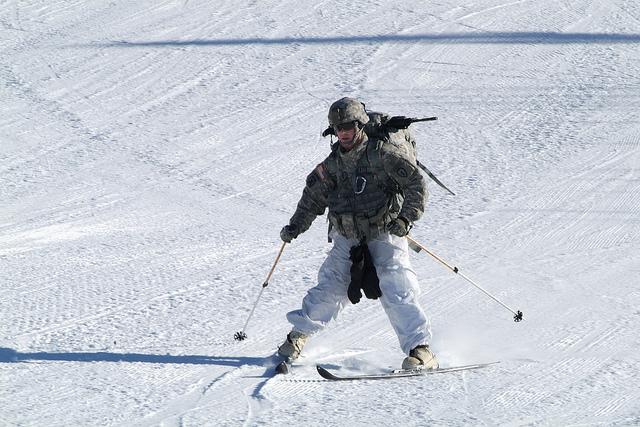Is this the first person to ski this trail today?
Give a very brief answer. No. What is this man holding?
Short answer required. Ski poles. What is this man doing?
Give a very brief answer. Skiing. 